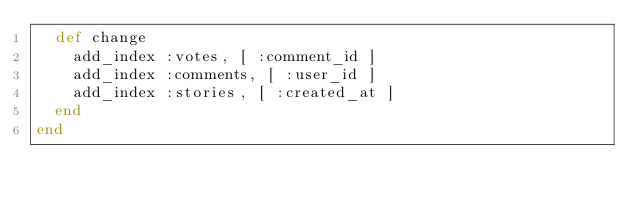<code> <loc_0><loc_0><loc_500><loc_500><_Ruby_>  def change
    add_index :votes, [ :comment_id ]
    add_index :comments, [ :user_id ]
    add_index :stories, [ :created_at ]
  end
end
</code> 